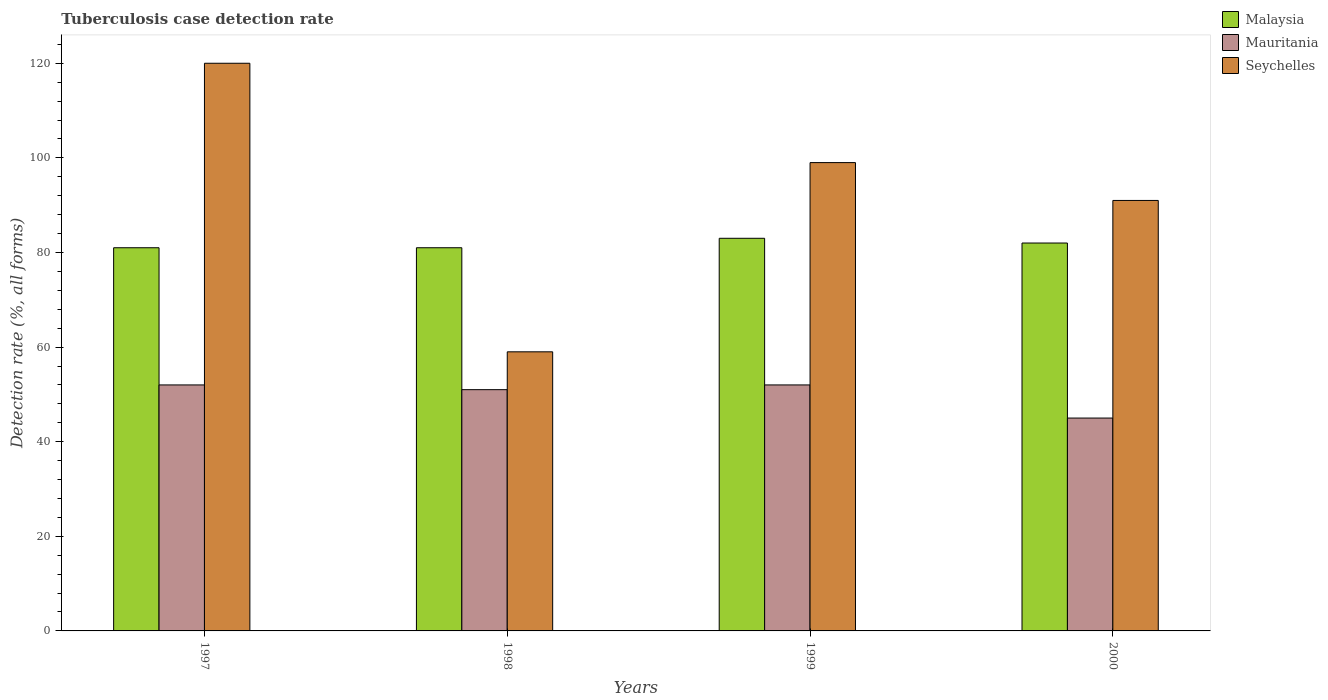Are the number of bars on each tick of the X-axis equal?
Offer a terse response. Yes. How many bars are there on the 3rd tick from the left?
Provide a short and direct response. 3. Across all years, what is the minimum tuberculosis case detection rate in in Mauritania?
Your response must be concise. 45. In which year was the tuberculosis case detection rate in in Malaysia minimum?
Offer a terse response. 1997. What is the total tuberculosis case detection rate in in Malaysia in the graph?
Make the answer very short. 327. What is the difference between the tuberculosis case detection rate in in Malaysia in 1997 and that in 1999?
Your response must be concise. -2. What is the difference between the tuberculosis case detection rate in in Seychelles in 1997 and the tuberculosis case detection rate in in Mauritania in 1999?
Your answer should be very brief. 68. What is the average tuberculosis case detection rate in in Seychelles per year?
Provide a succinct answer. 92.25. What is the ratio of the tuberculosis case detection rate in in Mauritania in 1998 to that in 2000?
Your answer should be very brief. 1.13. Is the tuberculosis case detection rate in in Seychelles in 1997 less than that in 1999?
Your answer should be very brief. No. Is the difference between the tuberculosis case detection rate in in Mauritania in 1999 and 2000 greater than the difference between the tuberculosis case detection rate in in Malaysia in 1999 and 2000?
Your answer should be very brief. Yes. What is the difference between the highest and the lowest tuberculosis case detection rate in in Malaysia?
Your response must be concise. 2. In how many years, is the tuberculosis case detection rate in in Seychelles greater than the average tuberculosis case detection rate in in Seychelles taken over all years?
Offer a terse response. 2. What does the 1st bar from the left in 1999 represents?
Ensure brevity in your answer.  Malaysia. What does the 3rd bar from the right in 2000 represents?
Make the answer very short. Malaysia. Is it the case that in every year, the sum of the tuberculosis case detection rate in in Seychelles and tuberculosis case detection rate in in Mauritania is greater than the tuberculosis case detection rate in in Malaysia?
Give a very brief answer. Yes. How many bars are there?
Give a very brief answer. 12. Does the graph contain grids?
Keep it short and to the point. No. How are the legend labels stacked?
Provide a succinct answer. Vertical. What is the title of the graph?
Your answer should be very brief. Tuberculosis case detection rate. What is the label or title of the Y-axis?
Your answer should be very brief. Detection rate (%, all forms). What is the Detection rate (%, all forms) in Malaysia in 1997?
Provide a short and direct response. 81. What is the Detection rate (%, all forms) of Mauritania in 1997?
Your answer should be very brief. 52. What is the Detection rate (%, all forms) of Seychelles in 1997?
Give a very brief answer. 120. What is the Detection rate (%, all forms) in Malaysia in 1998?
Your answer should be very brief. 81. What is the Detection rate (%, all forms) in Mauritania in 1998?
Keep it short and to the point. 51. What is the Detection rate (%, all forms) of Seychelles in 1998?
Offer a very short reply. 59. What is the Detection rate (%, all forms) of Mauritania in 1999?
Your response must be concise. 52. What is the Detection rate (%, all forms) of Seychelles in 1999?
Provide a succinct answer. 99. What is the Detection rate (%, all forms) of Malaysia in 2000?
Your answer should be very brief. 82. What is the Detection rate (%, all forms) of Seychelles in 2000?
Make the answer very short. 91. Across all years, what is the maximum Detection rate (%, all forms) of Malaysia?
Your answer should be very brief. 83. Across all years, what is the maximum Detection rate (%, all forms) in Seychelles?
Your answer should be compact. 120. Across all years, what is the minimum Detection rate (%, all forms) in Malaysia?
Offer a terse response. 81. Across all years, what is the minimum Detection rate (%, all forms) in Mauritania?
Offer a terse response. 45. What is the total Detection rate (%, all forms) in Malaysia in the graph?
Your response must be concise. 327. What is the total Detection rate (%, all forms) of Mauritania in the graph?
Ensure brevity in your answer.  200. What is the total Detection rate (%, all forms) of Seychelles in the graph?
Your response must be concise. 369. What is the difference between the Detection rate (%, all forms) of Malaysia in 1997 and that in 1998?
Ensure brevity in your answer.  0. What is the difference between the Detection rate (%, all forms) of Mauritania in 1997 and that in 1999?
Make the answer very short. 0. What is the difference between the Detection rate (%, all forms) of Seychelles in 1997 and that in 1999?
Offer a very short reply. 21. What is the difference between the Detection rate (%, all forms) of Malaysia in 1997 and that in 2000?
Make the answer very short. -1. What is the difference between the Detection rate (%, all forms) in Mauritania in 1997 and that in 2000?
Your response must be concise. 7. What is the difference between the Detection rate (%, all forms) of Seychelles in 1997 and that in 2000?
Provide a short and direct response. 29. What is the difference between the Detection rate (%, all forms) in Seychelles in 1998 and that in 1999?
Give a very brief answer. -40. What is the difference between the Detection rate (%, all forms) of Malaysia in 1998 and that in 2000?
Offer a very short reply. -1. What is the difference between the Detection rate (%, all forms) of Seychelles in 1998 and that in 2000?
Your answer should be very brief. -32. What is the difference between the Detection rate (%, all forms) in Malaysia in 1999 and that in 2000?
Make the answer very short. 1. What is the difference between the Detection rate (%, all forms) of Seychelles in 1999 and that in 2000?
Offer a terse response. 8. What is the difference between the Detection rate (%, all forms) in Malaysia in 1997 and the Detection rate (%, all forms) in Mauritania in 1998?
Ensure brevity in your answer.  30. What is the difference between the Detection rate (%, all forms) of Malaysia in 1997 and the Detection rate (%, all forms) of Seychelles in 1998?
Provide a succinct answer. 22. What is the difference between the Detection rate (%, all forms) of Mauritania in 1997 and the Detection rate (%, all forms) of Seychelles in 1999?
Offer a very short reply. -47. What is the difference between the Detection rate (%, all forms) of Malaysia in 1997 and the Detection rate (%, all forms) of Seychelles in 2000?
Your answer should be compact. -10. What is the difference between the Detection rate (%, all forms) in Mauritania in 1997 and the Detection rate (%, all forms) in Seychelles in 2000?
Offer a very short reply. -39. What is the difference between the Detection rate (%, all forms) in Malaysia in 1998 and the Detection rate (%, all forms) in Seychelles in 1999?
Offer a terse response. -18. What is the difference between the Detection rate (%, all forms) of Mauritania in 1998 and the Detection rate (%, all forms) of Seychelles in 1999?
Your answer should be compact. -48. What is the difference between the Detection rate (%, all forms) of Malaysia in 1998 and the Detection rate (%, all forms) of Seychelles in 2000?
Provide a succinct answer. -10. What is the difference between the Detection rate (%, all forms) in Malaysia in 1999 and the Detection rate (%, all forms) in Mauritania in 2000?
Make the answer very short. 38. What is the difference between the Detection rate (%, all forms) in Mauritania in 1999 and the Detection rate (%, all forms) in Seychelles in 2000?
Offer a very short reply. -39. What is the average Detection rate (%, all forms) in Malaysia per year?
Provide a short and direct response. 81.75. What is the average Detection rate (%, all forms) of Seychelles per year?
Provide a short and direct response. 92.25. In the year 1997, what is the difference between the Detection rate (%, all forms) in Malaysia and Detection rate (%, all forms) in Mauritania?
Your answer should be very brief. 29. In the year 1997, what is the difference between the Detection rate (%, all forms) in Malaysia and Detection rate (%, all forms) in Seychelles?
Keep it short and to the point. -39. In the year 1997, what is the difference between the Detection rate (%, all forms) in Mauritania and Detection rate (%, all forms) in Seychelles?
Ensure brevity in your answer.  -68. In the year 1999, what is the difference between the Detection rate (%, all forms) of Mauritania and Detection rate (%, all forms) of Seychelles?
Give a very brief answer. -47. In the year 2000, what is the difference between the Detection rate (%, all forms) of Malaysia and Detection rate (%, all forms) of Seychelles?
Keep it short and to the point. -9. In the year 2000, what is the difference between the Detection rate (%, all forms) of Mauritania and Detection rate (%, all forms) of Seychelles?
Provide a succinct answer. -46. What is the ratio of the Detection rate (%, all forms) in Malaysia in 1997 to that in 1998?
Your response must be concise. 1. What is the ratio of the Detection rate (%, all forms) of Mauritania in 1997 to that in 1998?
Ensure brevity in your answer.  1.02. What is the ratio of the Detection rate (%, all forms) in Seychelles in 1997 to that in 1998?
Give a very brief answer. 2.03. What is the ratio of the Detection rate (%, all forms) in Malaysia in 1997 to that in 1999?
Provide a succinct answer. 0.98. What is the ratio of the Detection rate (%, all forms) in Mauritania in 1997 to that in 1999?
Offer a terse response. 1. What is the ratio of the Detection rate (%, all forms) of Seychelles in 1997 to that in 1999?
Make the answer very short. 1.21. What is the ratio of the Detection rate (%, all forms) of Malaysia in 1997 to that in 2000?
Your answer should be very brief. 0.99. What is the ratio of the Detection rate (%, all forms) in Mauritania in 1997 to that in 2000?
Provide a succinct answer. 1.16. What is the ratio of the Detection rate (%, all forms) in Seychelles in 1997 to that in 2000?
Make the answer very short. 1.32. What is the ratio of the Detection rate (%, all forms) in Malaysia in 1998 to that in 1999?
Provide a succinct answer. 0.98. What is the ratio of the Detection rate (%, all forms) of Mauritania in 1998 to that in 1999?
Make the answer very short. 0.98. What is the ratio of the Detection rate (%, all forms) of Seychelles in 1998 to that in 1999?
Give a very brief answer. 0.6. What is the ratio of the Detection rate (%, all forms) in Malaysia in 1998 to that in 2000?
Offer a very short reply. 0.99. What is the ratio of the Detection rate (%, all forms) of Mauritania in 1998 to that in 2000?
Keep it short and to the point. 1.13. What is the ratio of the Detection rate (%, all forms) of Seychelles in 1998 to that in 2000?
Give a very brief answer. 0.65. What is the ratio of the Detection rate (%, all forms) in Malaysia in 1999 to that in 2000?
Provide a short and direct response. 1.01. What is the ratio of the Detection rate (%, all forms) in Mauritania in 1999 to that in 2000?
Provide a succinct answer. 1.16. What is the ratio of the Detection rate (%, all forms) of Seychelles in 1999 to that in 2000?
Ensure brevity in your answer.  1.09. What is the difference between the highest and the second highest Detection rate (%, all forms) in Mauritania?
Make the answer very short. 0. What is the difference between the highest and the second highest Detection rate (%, all forms) in Seychelles?
Make the answer very short. 21. What is the difference between the highest and the lowest Detection rate (%, all forms) of Malaysia?
Your response must be concise. 2. What is the difference between the highest and the lowest Detection rate (%, all forms) of Mauritania?
Your answer should be very brief. 7. 